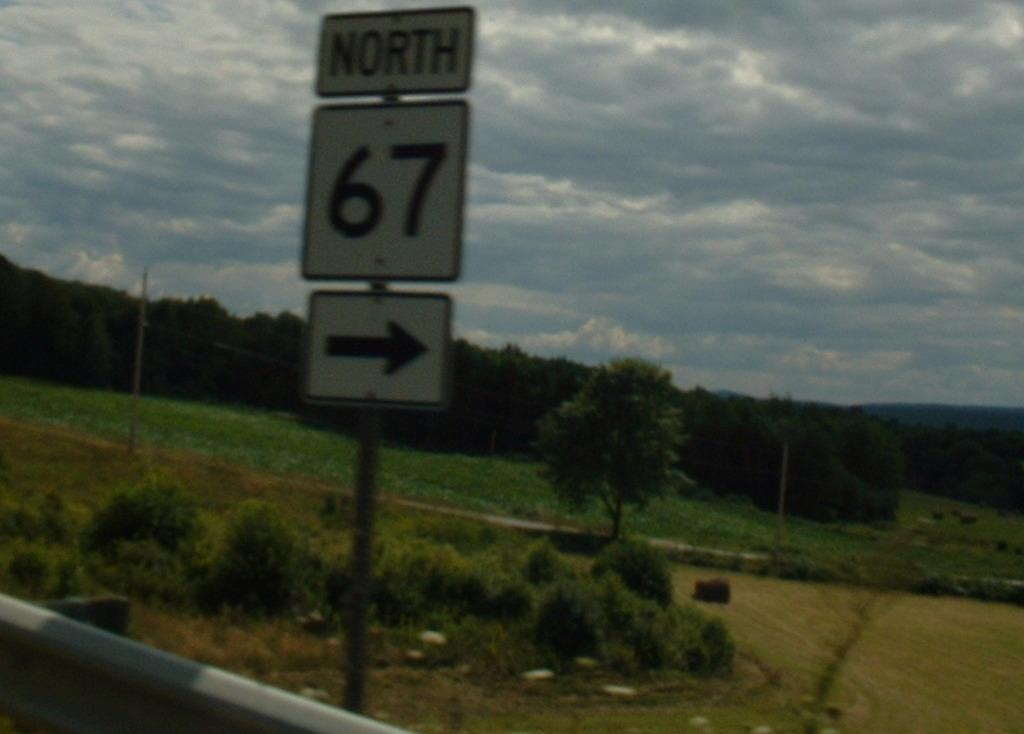Provide a one-sentence caption for the provided image. Outside sign on the road telling drivers North 67 is on the right. 